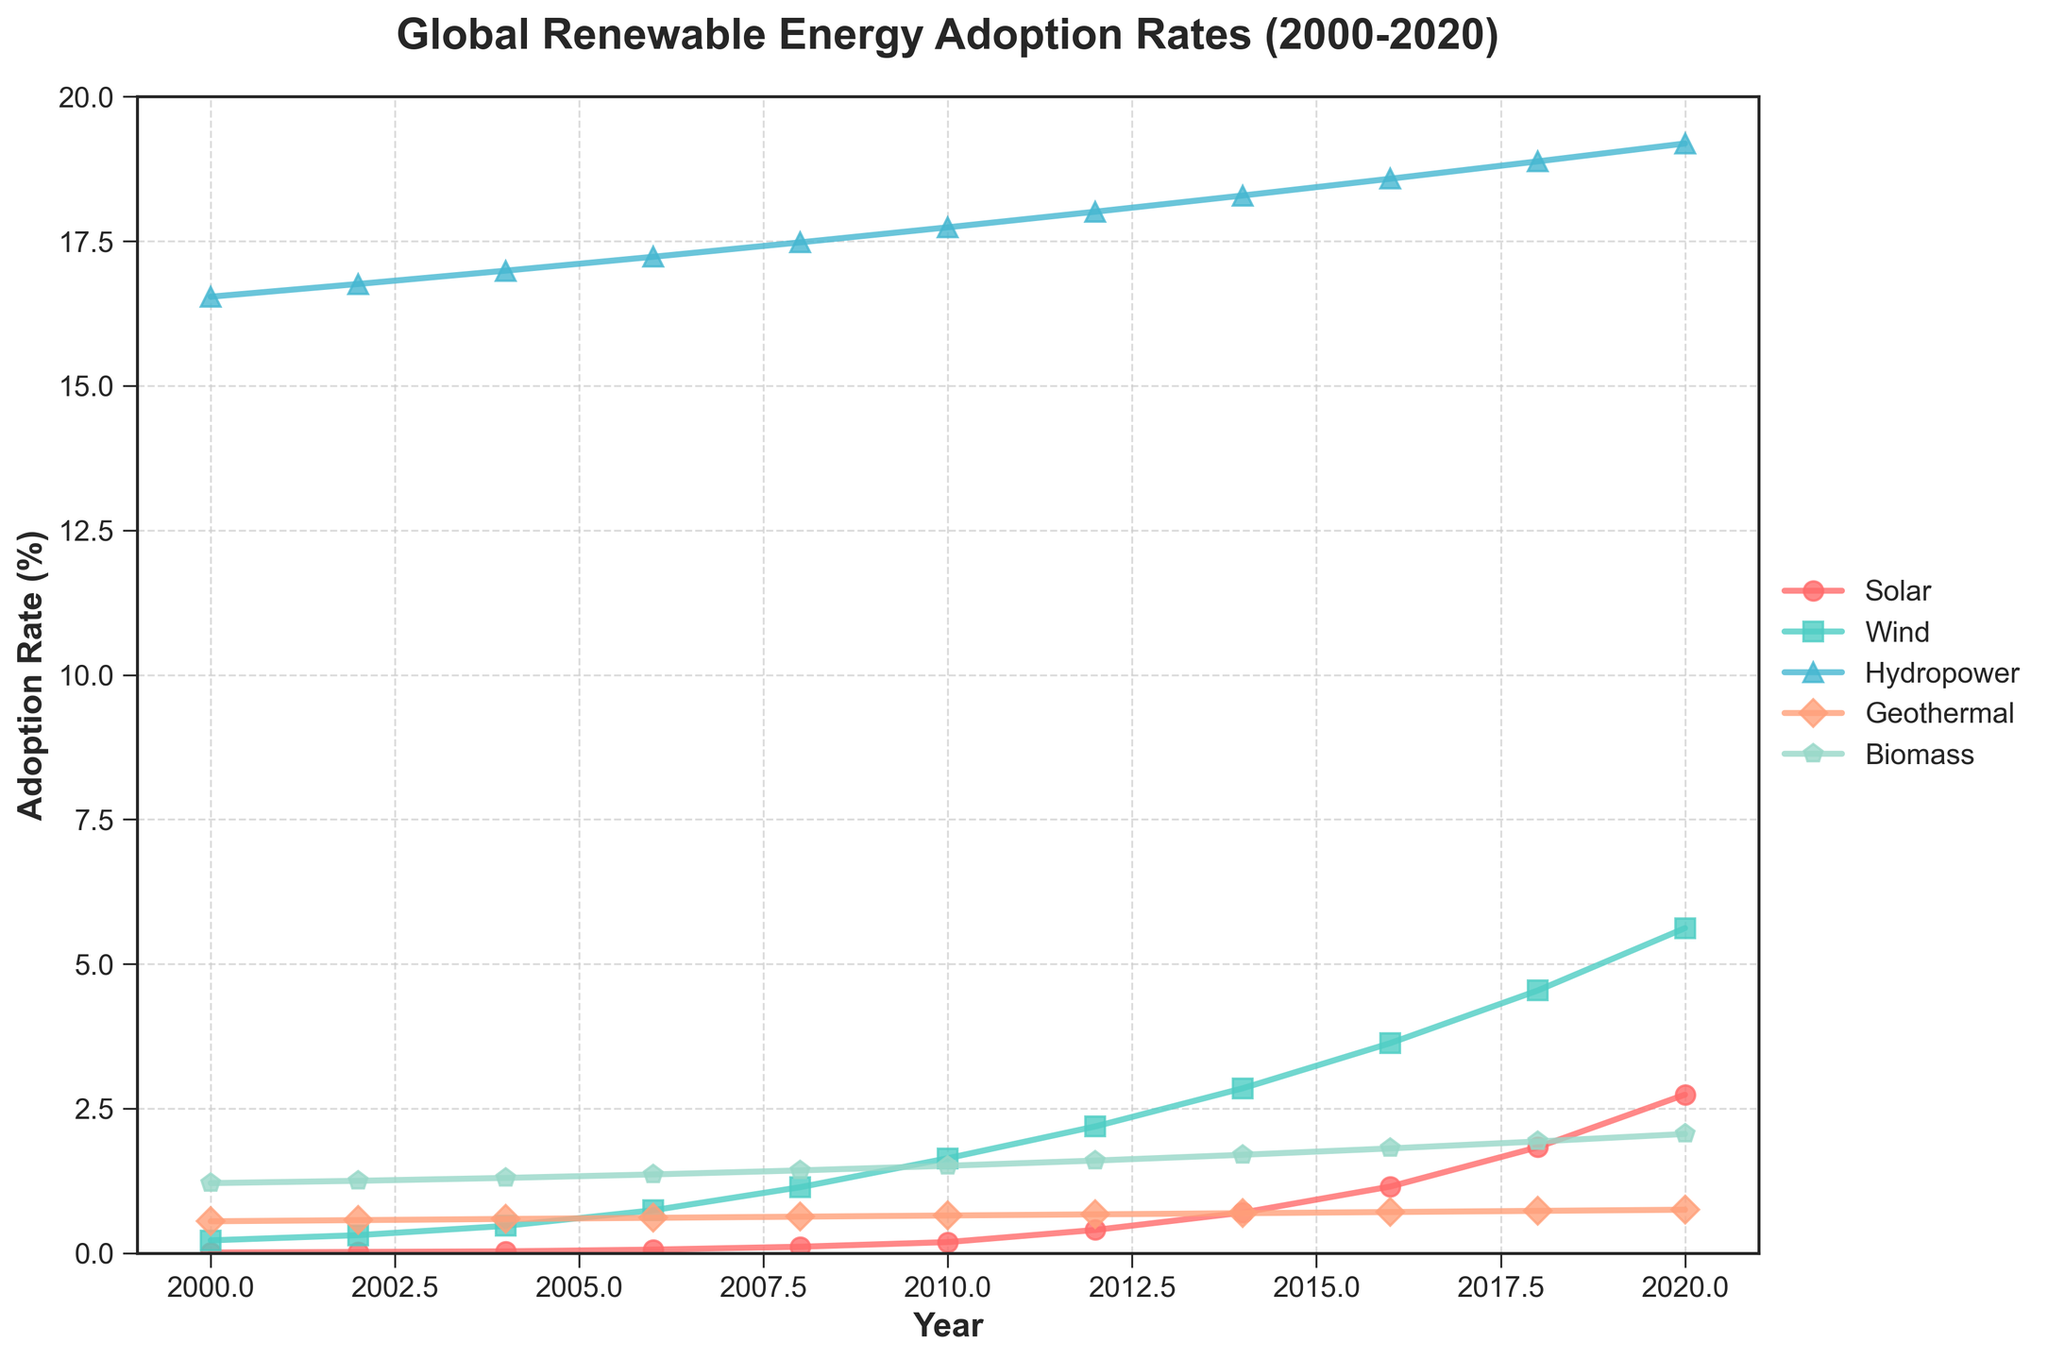What is the overall trend of solar energy adoption from 2000 to 2020? Solar energy adoption shows a clear increasing trend over the two decades. Starting from almost negligible at 0.01% in 2000, it continuously rises to 2.74% by 2020.
Answer: Increasing In which year did wind energy adoption first exceed 3%? Looking at the wind energy adoption line, it first crosses the 3% mark in the year 2016.
Answer: 2016 Which energy source had the highest adoption rate in 2010? By visually inspecting the chart for the year 2010, it's clear that hydropower had the highest adoption rate at 17.74%.
Answer: Hydropower Compare the adoption rates of solar and biomass energy in 2020. Which one was higher and by how much? In 2020, solar energy adoption was at 2.74%, while biomass energy stood at 2.06%. Subtracting these gives 2.74% - 2.06% = 0.68%. Thus, solar energy adoption was higher by 0.68%.
Answer: Solar by 0.68% What is the average adoption rate of geothermal energy over the two decades? To find the average, sum all the geothermal adoption rates and then divide by the total number of years. (0.55 + 0.57 + 0.59 + 0.61 + 0.63 + 0.65 + 0.67 + 0.69 + 0.71 + 0.73 + 0.75)/11 = 0.65%.
Answer: 0.65% Which energy source experienced the most significant growth between 2000 and 2020? By comparing 2020 adoption rates with those in 2000 for all sources, solar increased from 0.01% to 2.74% (2.73%), wind from 0.22% to 5.62% (5.4%), hydropower from 16.54% to 19.19% (2.65%), geothermal from 0.55% to 0.75% (0.2%), and biomass from 1.21% to 2.06% (0.85%). Wind energy experienced the most significant growth at 5.4%.
Answer: Wind In what year did biomass energy adoption rate reach 1.5%? Checking the biomass line on the chart, we see that it reached 1.51% in the year 2010.
Answer: 2010 By how much did the adoption rate of hydropower increase from 2000 to 2020? Hydropower adoption was 16.54% in 2000 and grew to 19.19% in 2020. The increase is 19.19% - 16.54% = 2.65%.
Answer: 2.65% What color represents wind energy in the chart and what is the marker used? By examining the visual attributes, wind energy is represented in green color with a square (s) marker.
Answer: Green with a square marker 